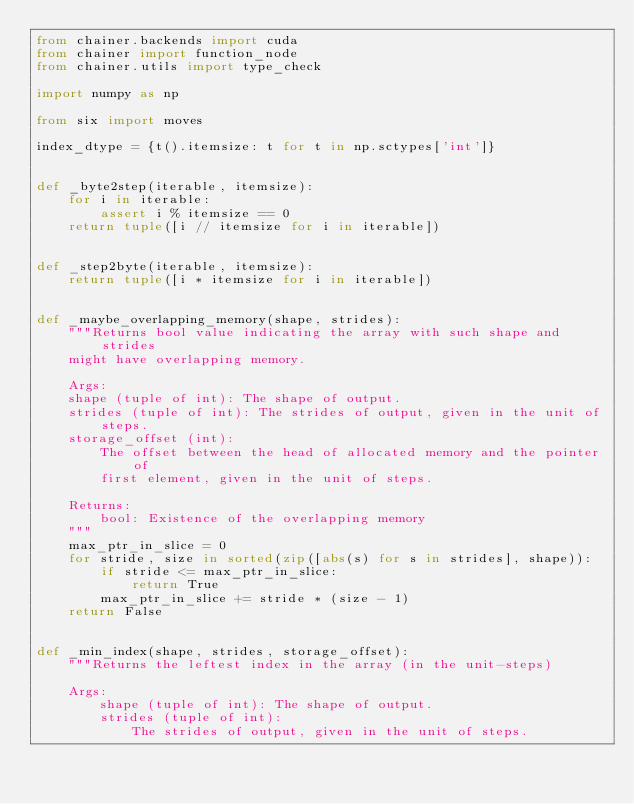Convert code to text. <code><loc_0><loc_0><loc_500><loc_500><_Python_>from chainer.backends import cuda
from chainer import function_node
from chainer.utils import type_check

import numpy as np

from six import moves

index_dtype = {t().itemsize: t for t in np.sctypes['int']}


def _byte2step(iterable, itemsize):
    for i in iterable:
        assert i % itemsize == 0
    return tuple([i // itemsize for i in iterable])


def _step2byte(iterable, itemsize):
    return tuple([i * itemsize for i in iterable])


def _maybe_overlapping_memory(shape, strides):
    """Returns bool value indicating the array with such shape and strides
    might have overlapping memory.

    Args:
    shape (tuple of int): The shape of output.
    strides (tuple of int): The strides of output, given in the unit of steps.
    storage_offset (int):
        The offset between the head of allocated memory and the pointer of
        first element, given in the unit of steps.

    Returns:
        bool: Existence of the overlapping memory
    """
    max_ptr_in_slice = 0
    for stride, size in sorted(zip([abs(s) for s in strides], shape)):
        if stride <= max_ptr_in_slice:
            return True
        max_ptr_in_slice += stride * (size - 1)
    return False


def _min_index(shape, strides, storage_offset):
    """Returns the leftest index in the array (in the unit-steps)

    Args:
        shape (tuple of int): The shape of output.
        strides (tuple of int):
            The strides of output, given in the unit of steps.</code> 